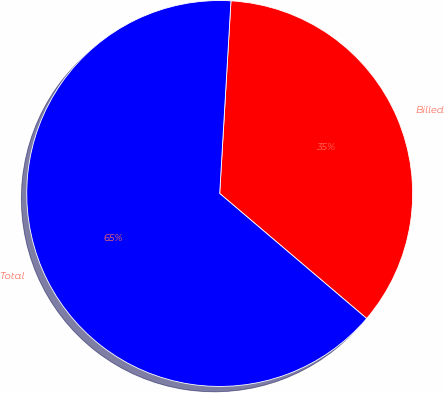<chart> <loc_0><loc_0><loc_500><loc_500><pie_chart><fcel>Billed<fcel>Total<nl><fcel>35.29%<fcel>64.71%<nl></chart> 